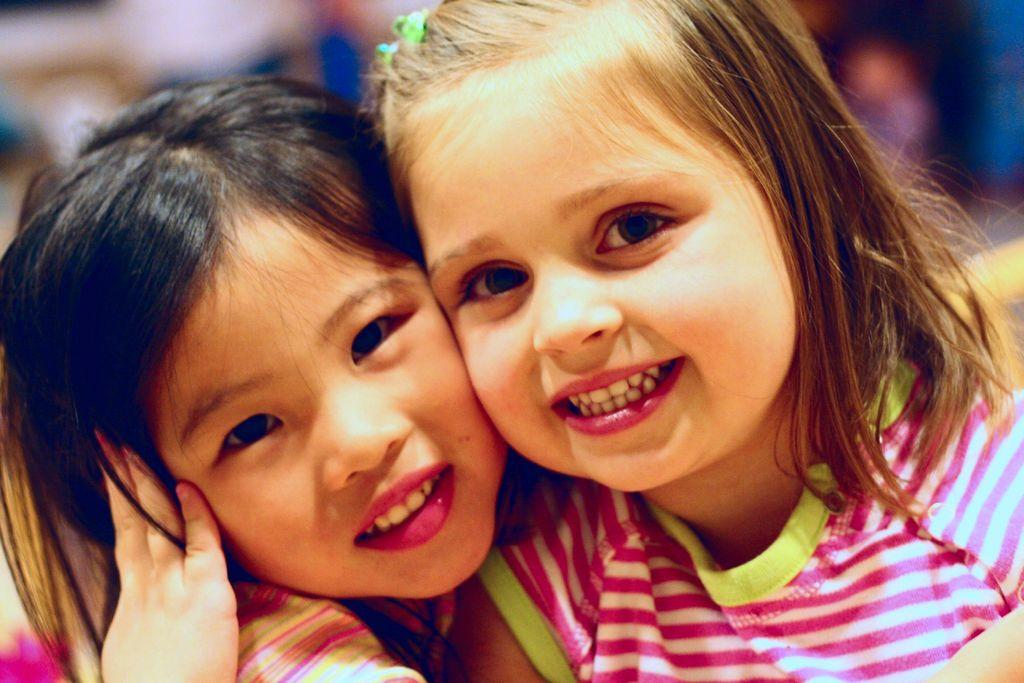How many people are in the image? There are two girls in the image. What can be observed about the background of the image? The background of the image includes blue and white colors. Can you tell me what type of knowledge the donkey is sharing with the girls in the image? There is no donkey present in the image, so it is not possible to determine what type of knowledge it might be sharing. 